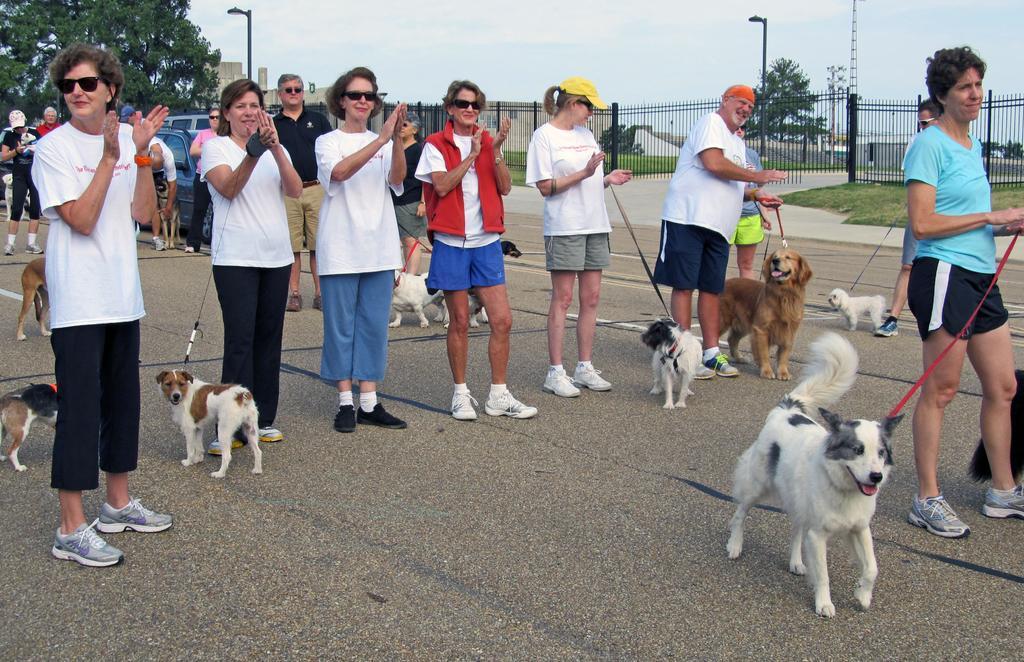Can you describe this image briefly? In the image we can see there are people standing on the road and they are holding the ropes which are tied around the neck of their dogs. Behind there are vehicles parked on the road and there are trees. The ground is covered with grass. 